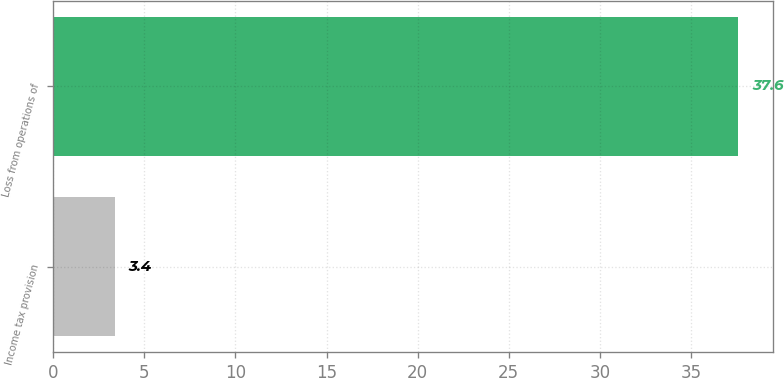Convert chart. <chart><loc_0><loc_0><loc_500><loc_500><bar_chart><fcel>Income tax provision<fcel>Loss from operations of<nl><fcel>3.4<fcel>37.6<nl></chart> 